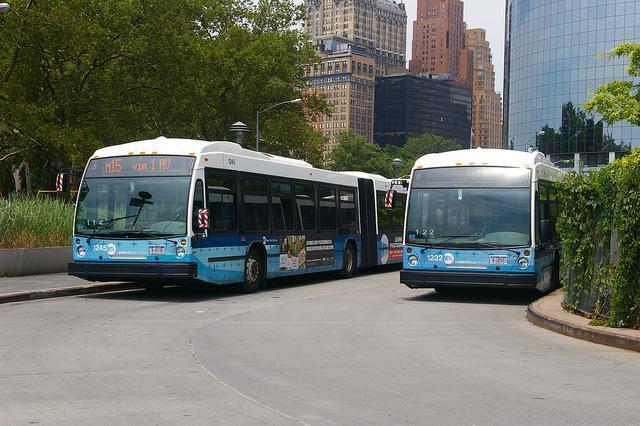How many busses are in the picture?
Give a very brief answer. 2. How many buses are there?
Give a very brief answer. 2. How many buses can you see?
Give a very brief answer. 2. 